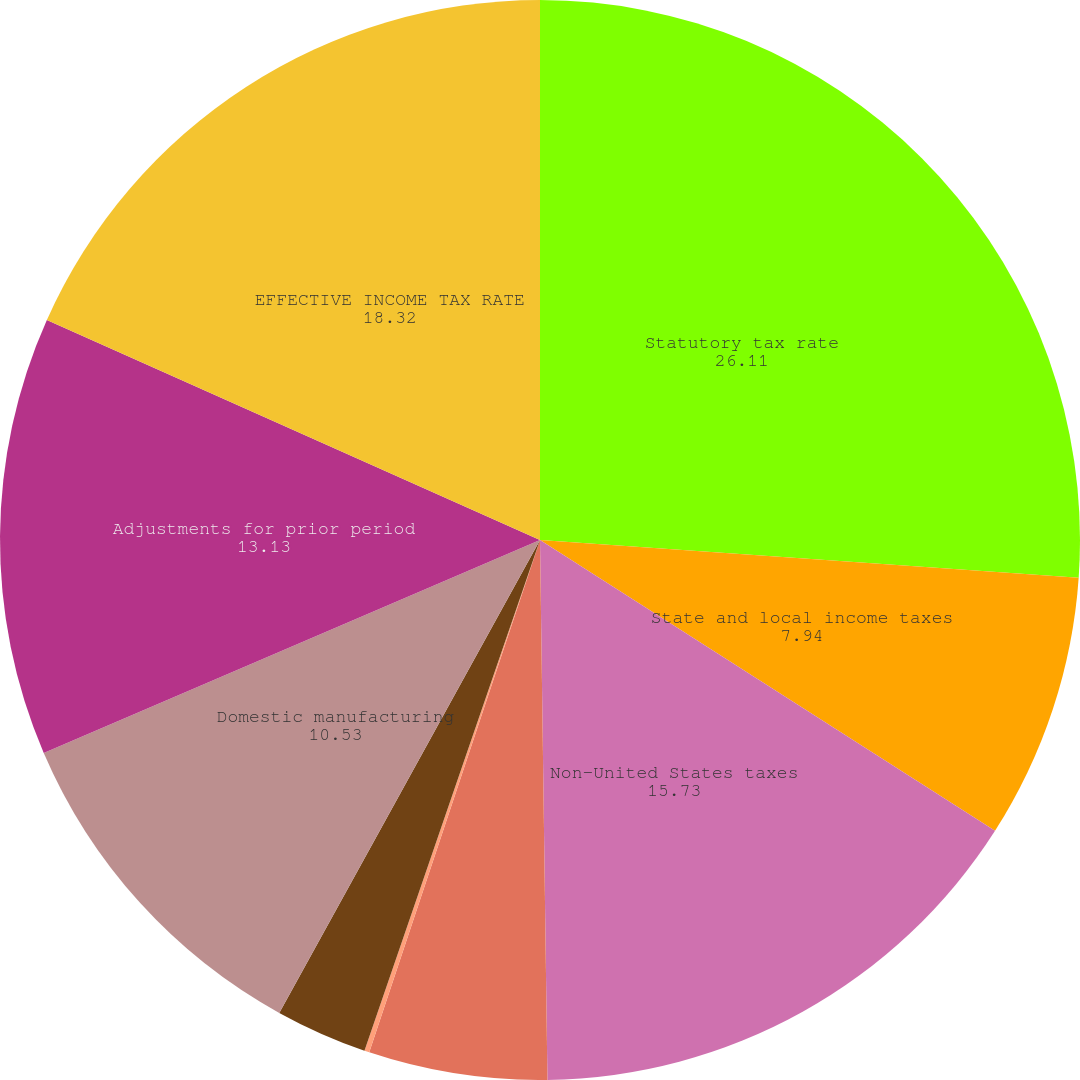<chart> <loc_0><loc_0><loc_500><loc_500><pie_chart><fcel>Statutory tax rate<fcel>State and local income taxes<fcel>Non-United States taxes<fcel>Foreign tax credit utilization<fcel>Employee stock ownership plan<fcel>Change in valuation allowances<fcel>Domestic manufacturing<fcel>Adjustments for prior period<fcel>EFFECTIVE INCOME TAX RATE<nl><fcel>26.11%<fcel>7.94%<fcel>15.73%<fcel>5.34%<fcel>0.15%<fcel>2.75%<fcel>10.53%<fcel>13.13%<fcel>18.32%<nl></chart> 